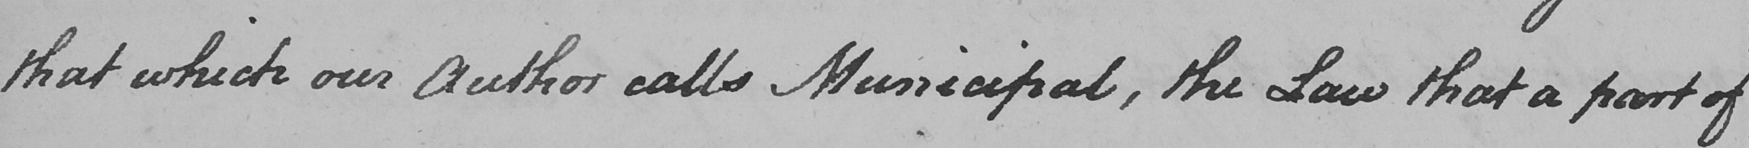Transcribe the text shown in this historical manuscript line. that which our Author calls Municipal , the Law that a part of 